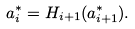<formula> <loc_0><loc_0><loc_500><loc_500>a _ { i } ^ { * } = H _ { i + 1 } ( a _ { i + 1 } ^ { * } ) .</formula> 